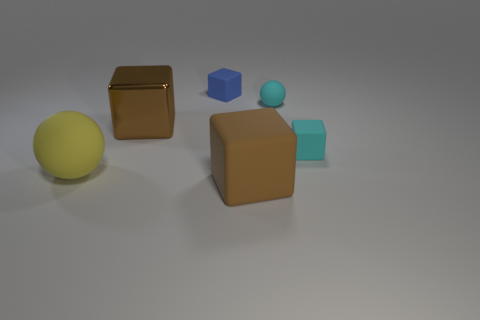There is a small rubber sphere; is it the same color as the tiny rubber block that is in front of the metal cube?
Give a very brief answer. Yes. What is the brown block that is behind the large yellow rubber thing made of?
Provide a succinct answer. Metal. Is there a rubber thing of the same color as the small ball?
Make the answer very short. Yes. What is the color of the matte ball that is the same size as the brown metal thing?
Give a very brief answer. Yellow. What number of tiny objects are brown metal objects or yellow matte things?
Offer a terse response. 0. Are there an equal number of tiny cyan spheres that are in front of the yellow rubber thing and large brown rubber things behind the small blue rubber block?
Keep it short and to the point. Yes. What number of green matte spheres are the same size as the metal thing?
Provide a short and direct response. 0. How many cyan objects are either large shiny things or large rubber objects?
Give a very brief answer. 0. Are there an equal number of matte balls in front of the small sphere and tiny blue metal things?
Keep it short and to the point. No. There is a brown thing behind the big yellow rubber object; what is its size?
Offer a terse response. Large. 